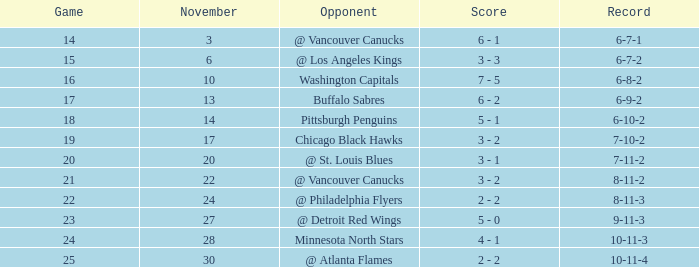What is the game when on november 27? 23.0. 